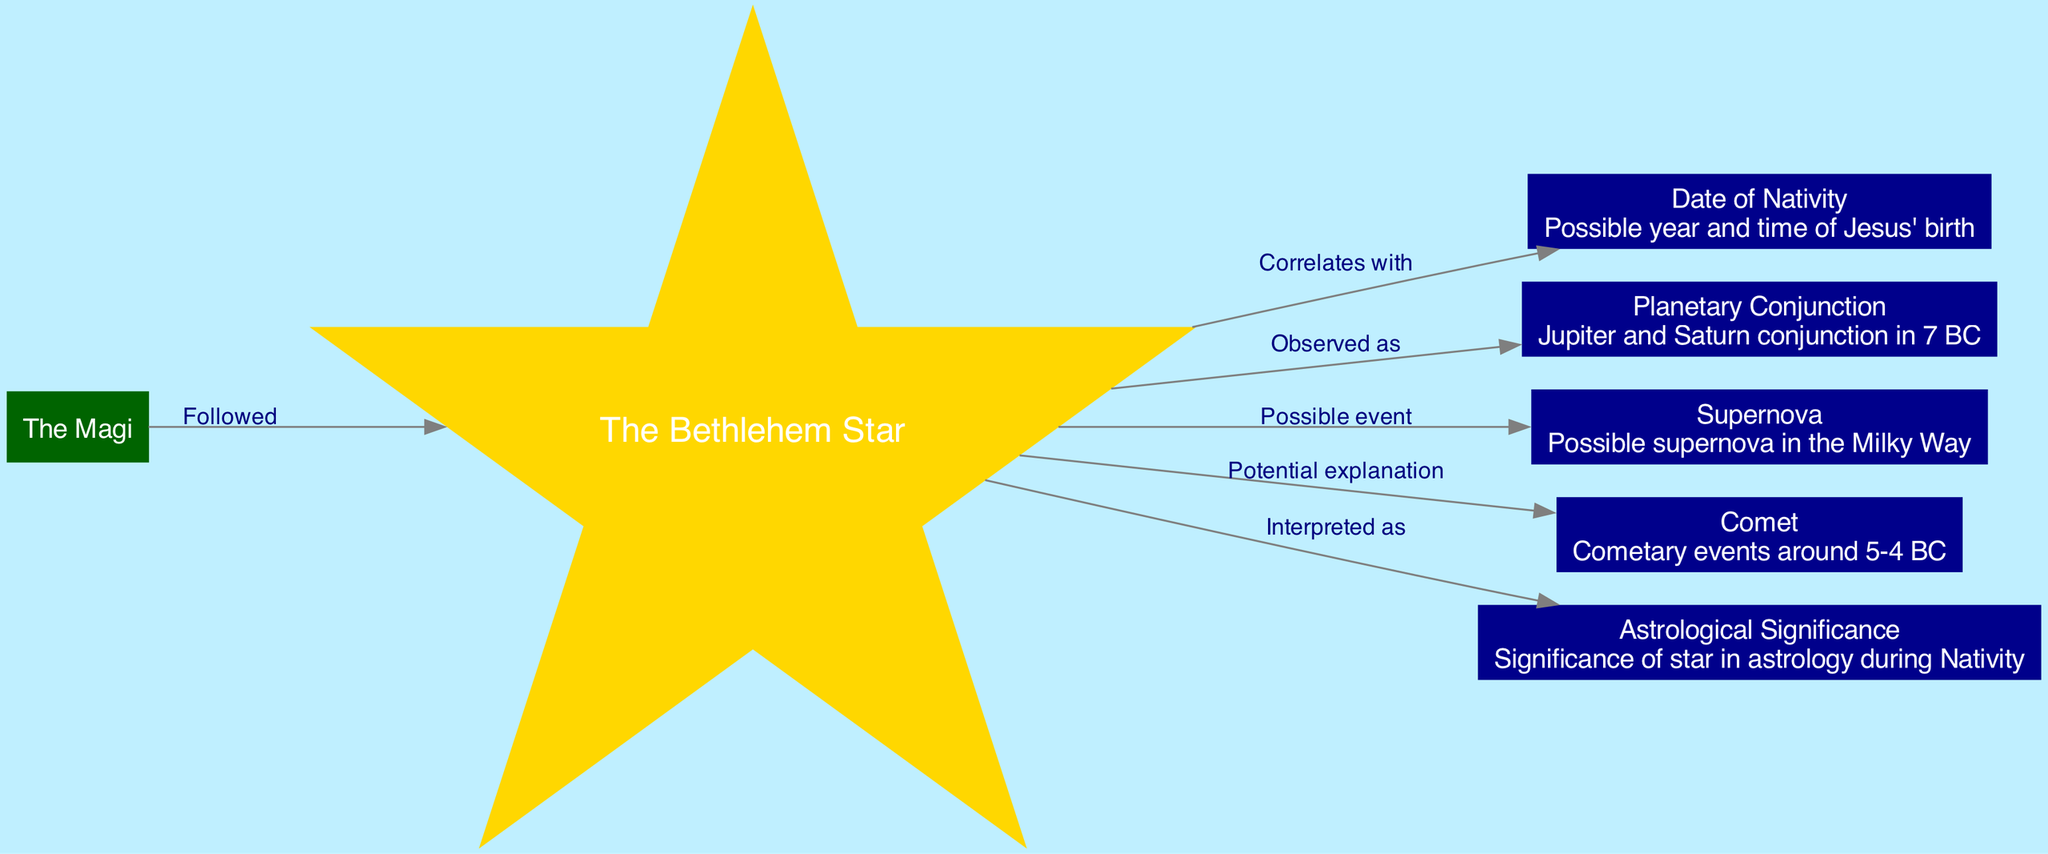what is the main subject of the diagram? The diagram focuses on "The Bethlehem Star" as its central theme, indicated clearly by the prominent node labeled as such.
Answer: The Bethlehem Star how many nodes are present in the diagram? The nodes represent various astronomical and historical elements related to the Bethlehem Star and there are a total of 7 nodes in the diagram as defined in the data.
Answer: 7 which node describes a significant astronomical event occurring in 7 BC? The node for "Planetary Conjunction" mentions the conjunction of Jupiter and Saturn as a significant event that could correlate with the star.
Answer: Planetary Conjunction what do the Magi follow to find the birthplace of Jesus? The connections in the diagram specify that the Magi followed "The Bethlehem Star" as indicated by the relevant arrow directed from the Magi to the star.
Answer: The Bethlehem Star what astronomical explanation is suggested by the edge connecting "Bethlehem Star" to "Comet"? The diagram indicates that a comet could potentially explain the phenomenon of the Bethlehem Star, as marked by the edge linking these two nodes.
Answer: Potential explanation how does the "Bethlehem Star" relate to the "Astrological Significance"? According to the diagram, the Bethlehem Star is interpreted as an important astrological omen during the time of the Nativity, as depicted by the respective edge.
Answer: Interpreted as why is the "Supernova" listed as a possible event related to "The Bethlehem Star"? The edge connecting "Bethlehem Star" to "Supernova" suggests that a bright supernova might have been observed, which feeds into the theories surrounding the nature of the star.
Answer: Possible event 